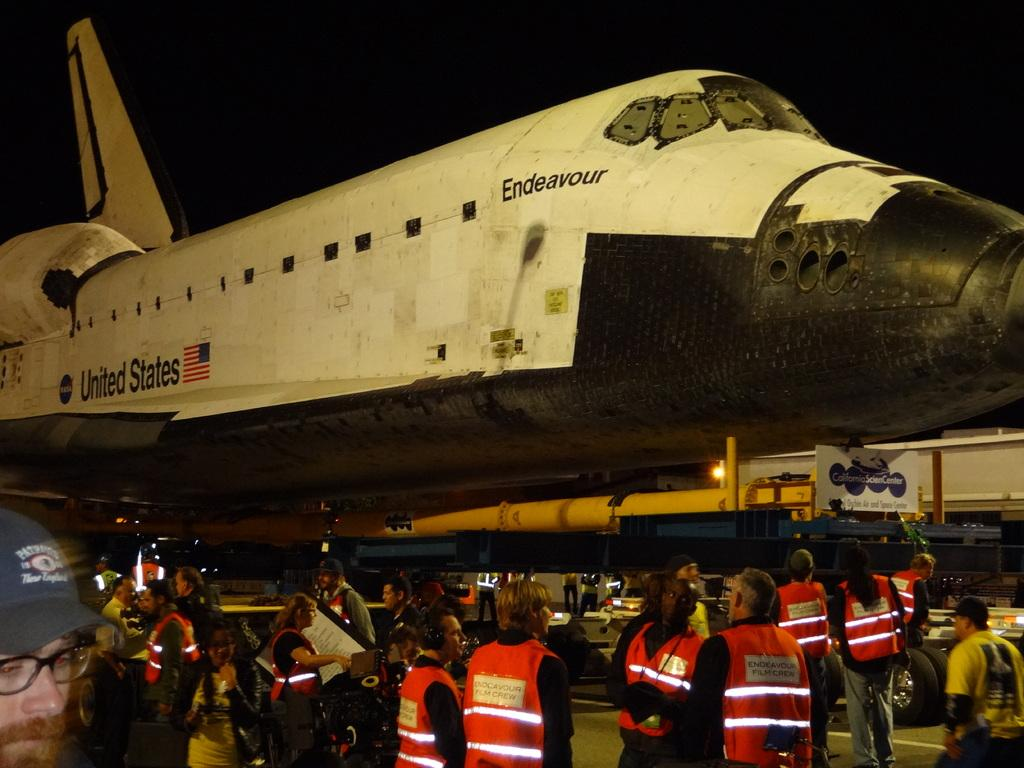What is located in the foreground of the image? There is a crowd and an aircraft on the road in the foreground of the image. What can be seen in the background of the image? Vehicles and the sky are visible in the background of the image. Can you describe the lighting conditions in the image? The image may have been taken during the night, as there is no indication of daylight. What type of cherry is being used to decorate the aircraft in the image? There is no cherry present in the image, and the aircraft is not being decorated. How does the balloon affect the plot of the image? There is no balloon or plot present in the image, as it is a photograph of a crowd, an aircraft, vehicles, and the sky. 